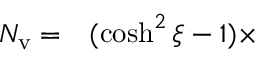<formula> <loc_0><loc_0><loc_500><loc_500>\begin{array} { r l } { N _ { v } = } & ( \cosh ^ { 2 } \xi - 1 ) \times } \end{array}</formula> 